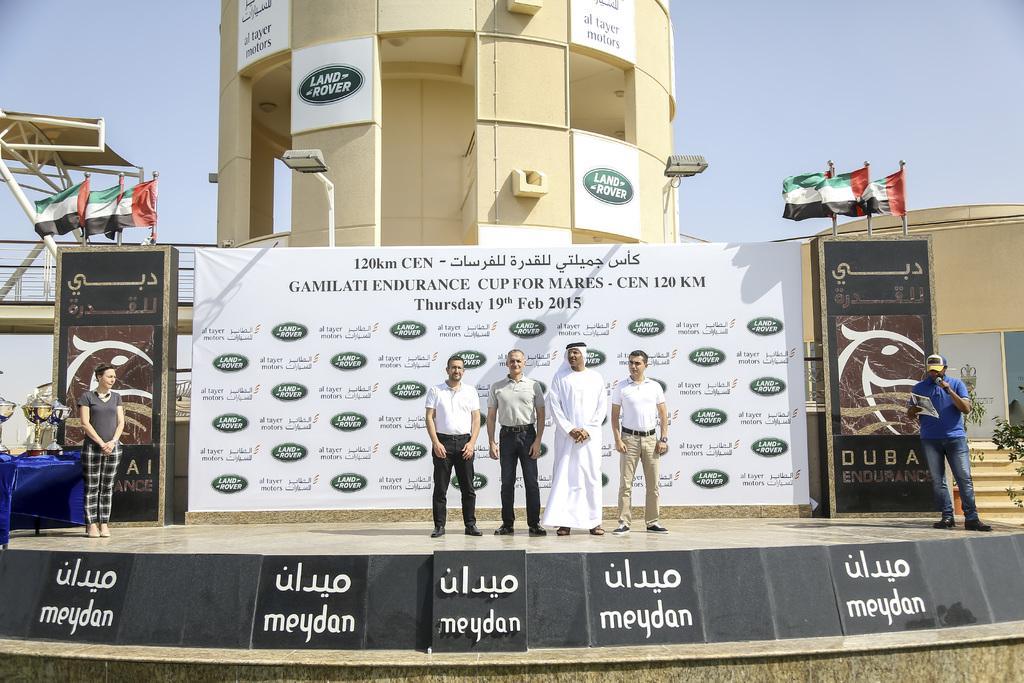Could you give a brief overview of what you see in this image? In this image in the front there are boards with some text written on it. In the center there are persons standing and smiling. In the background there are boards with some text written on it and on the top of the boards there are flags, there is a building and on the wall of the building there are boards with some text written on it. On the right side, in the background there is a building and on the right side there are plants. On the left side in the background there is a bridge and there is a shoulder and in the center there is an object which is blue in colour and on the object there are cups. 